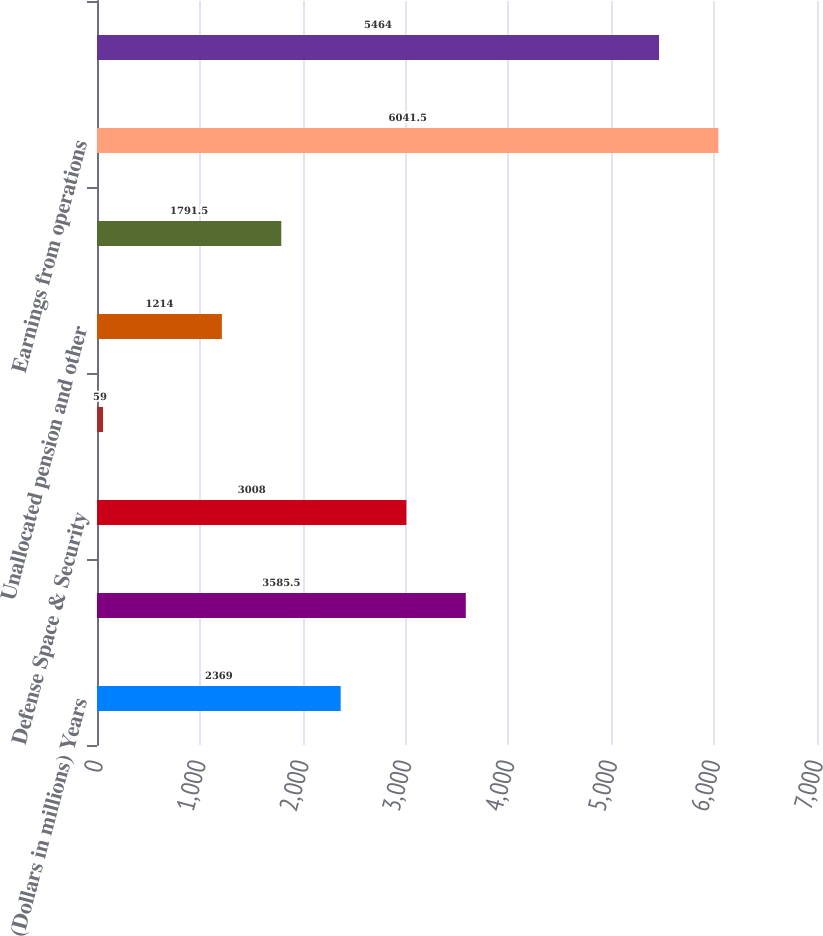Convert chart to OTSL. <chart><loc_0><loc_0><loc_500><loc_500><bar_chart><fcel>(Dollars in millions) Years<fcel>Commercial Airplanes<fcel>Defense Space & Security<fcel>Boeing Capital<fcel>Unallocated pension and other<fcel>Other unallocated items and<fcel>Earnings from operations<fcel>Core operating earnings<nl><fcel>2369<fcel>3585.5<fcel>3008<fcel>59<fcel>1214<fcel>1791.5<fcel>6041.5<fcel>5464<nl></chart> 